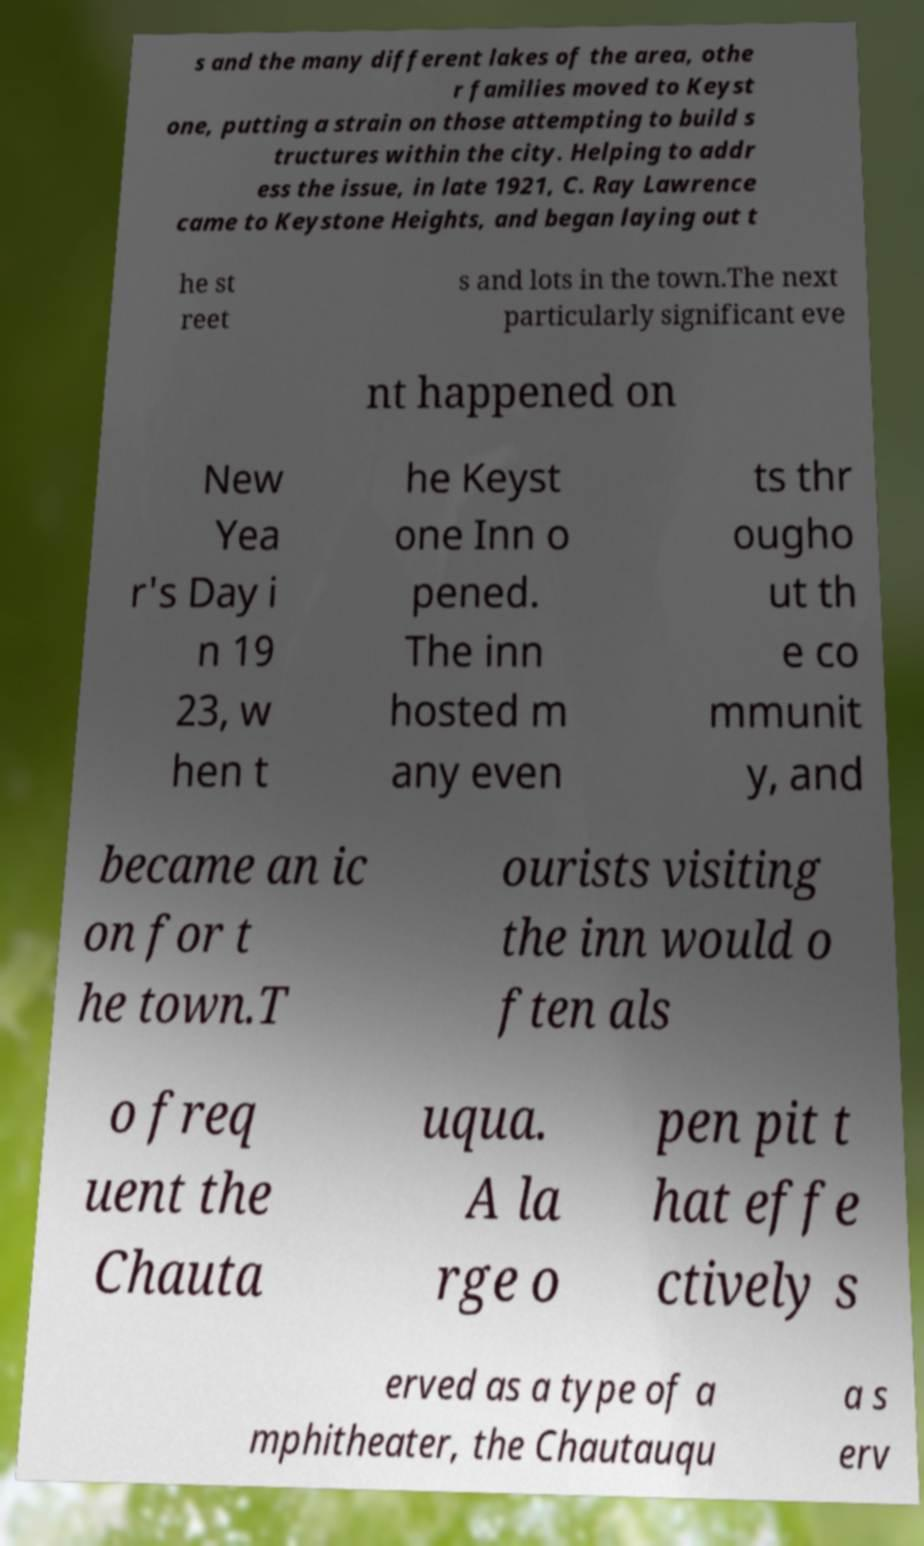For documentation purposes, I need the text within this image transcribed. Could you provide that? s and the many different lakes of the area, othe r families moved to Keyst one, putting a strain on those attempting to build s tructures within the city. Helping to addr ess the issue, in late 1921, C. Ray Lawrence came to Keystone Heights, and began laying out t he st reet s and lots in the town.The next particularly significant eve nt happened on New Yea r's Day i n 19 23, w hen t he Keyst one Inn o pened. The inn hosted m any even ts thr ougho ut th e co mmunit y, and became an ic on for t he town.T ourists visiting the inn would o ften als o freq uent the Chauta uqua. A la rge o pen pit t hat effe ctively s erved as a type of a mphitheater, the Chautauqu a s erv 